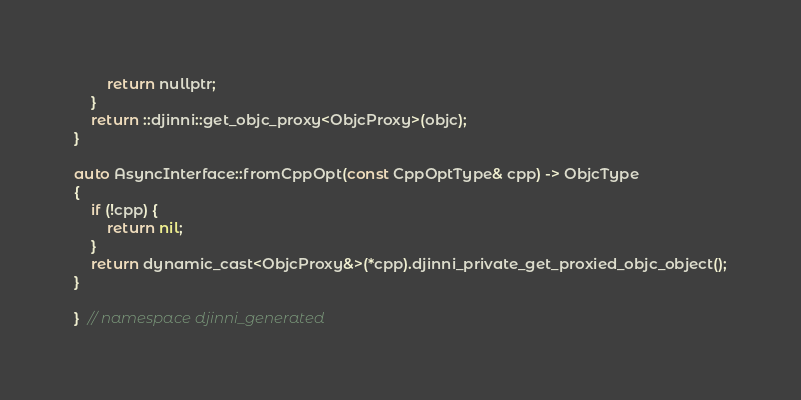Convert code to text. <code><loc_0><loc_0><loc_500><loc_500><_ObjectiveC_>        return nullptr;
    }
    return ::djinni::get_objc_proxy<ObjcProxy>(objc);
}

auto AsyncInterface::fromCppOpt(const CppOptType& cpp) -> ObjcType
{
    if (!cpp) {
        return nil;
    }
    return dynamic_cast<ObjcProxy&>(*cpp).djinni_private_get_proxied_objc_object();
}

}  // namespace djinni_generated
</code> 